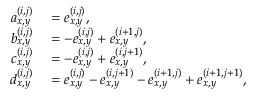Convert formula to latex. <formula><loc_0><loc_0><loc_500><loc_500>\begin{array} { r l } { a _ { x , y } ^ { ( i , j ) } } & = e _ { x , y } ^ { ( i , j ) } , } \\ { b _ { x , y } ^ { ( i , j ) } } & = - e _ { x , y } ^ { ( i , j ) } + e _ { x , y } ^ { ( i + 1 , j ) } , } \\ { c _ { x , y } ^ { ( i , j ) } } & = - e _ { x , y } ^ { ( i , j ) } + e _ { x , y } ^ { ( i , j + 1 ) } , } \\ { d _ { x , y } ^ { ( i , j ) } } & = e _ { x , y } ^ { ( i , j ) } - e _ { x , y } ^ { ( i , j + 1 ) } - e _ { x , y } ^ { ( i + 1 , j ) } + e _ { x , y } ^ { ( i + 1 , j + 1 ) } , } \end{array}</formula> 